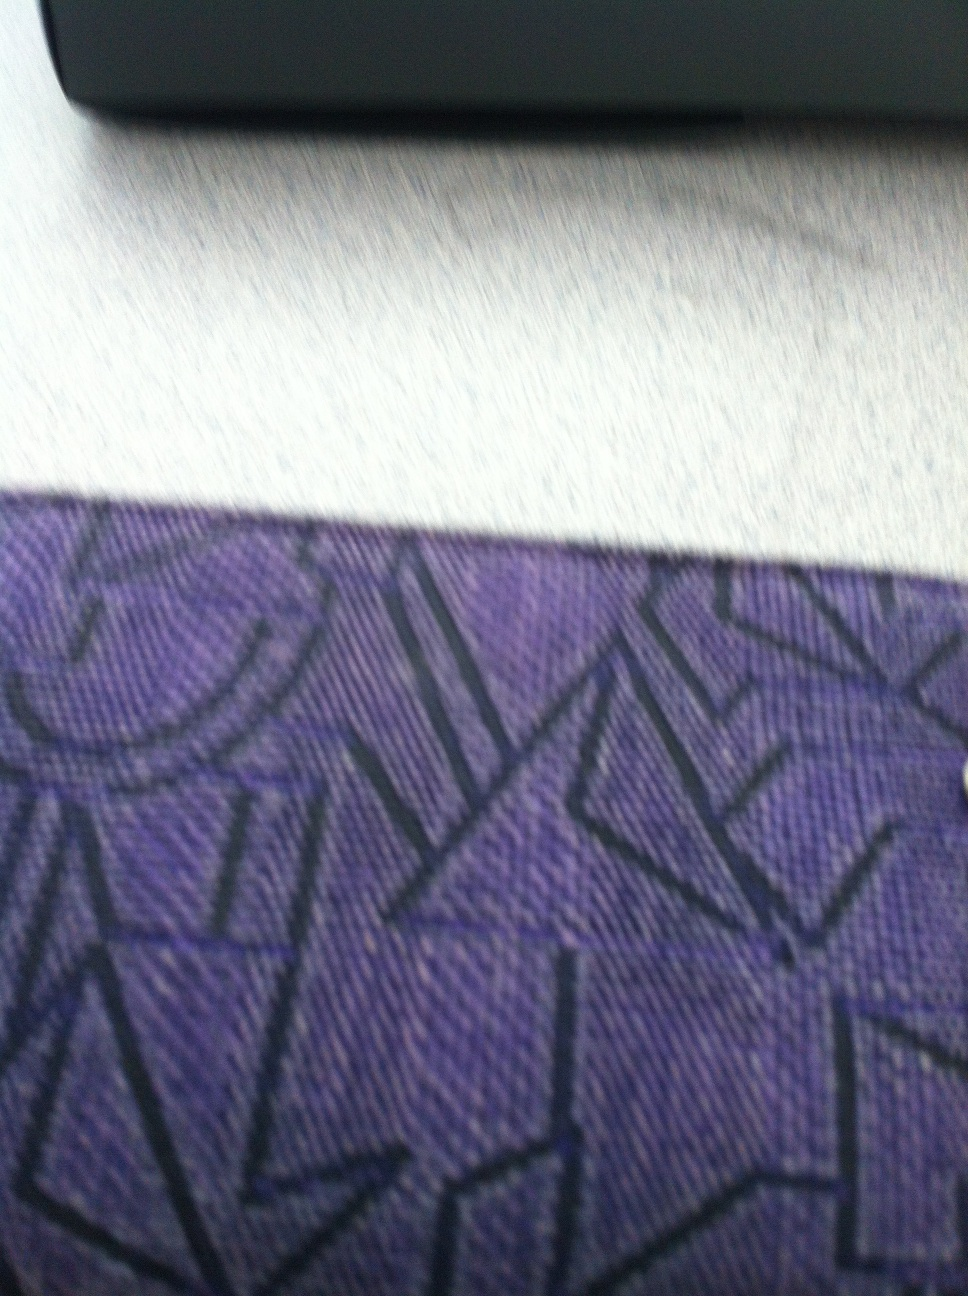Imagine a story where this wallet travels the world. What adventures might it have? Once upon a time, your purple geometric-patterned wallet embarked on a grand adventure around the globe. It visited the bustling streets of Tokyo, where it was admired for its unique design. Then, it traveled to the romantic cafes of Paris, slipping out just in time to catch a musician strumming a soulful tune. At each destination, the wallet collected memories and small trinkets, symbolizing its journey. From the sun-kissed beaches of Bali to the historic lanes of Rome, the wallet became a treasure trove of stories, each pattern weaving a tale of places seen and experiences shared. 